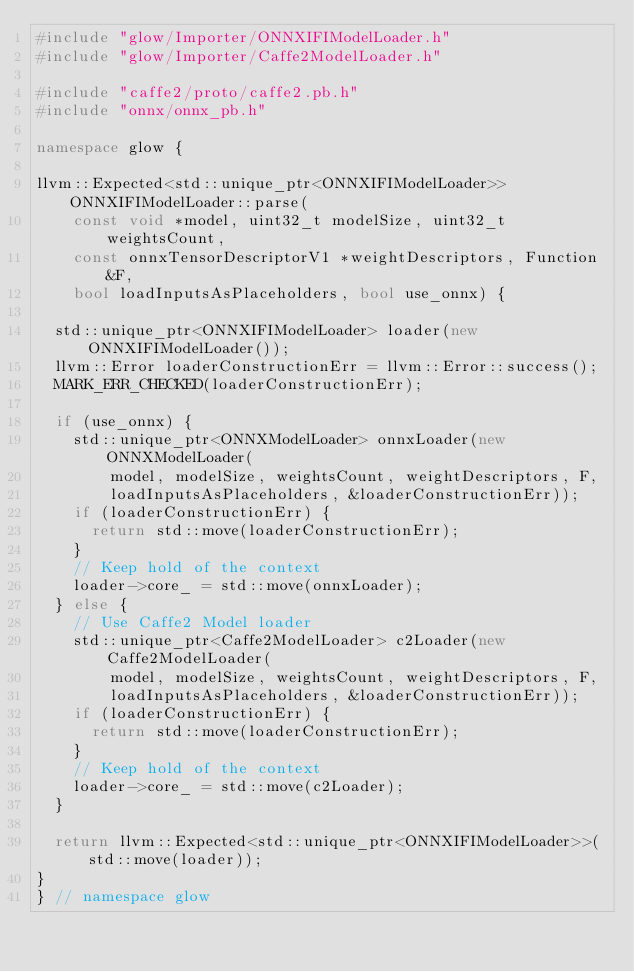<code> <loc_0><loc_0><loc_500><loc_500><_C++_>#include "glow/Importer/ONNXIFIModelLoader.h"
#include "glow/Importer/Caffe2ModelLoader.h"

#include "caffe2/proto/caffe2.pb.h"
#include "onnx/onnx_pb.h"

namespace glow {

llvm::Expected<std::unique_ptr<ONNXIFIModelLoader>> ONNXIFIModelLoader::parse(
    const void *model, uint32_t modelSize, uint32_t weightsCount,
    const onnxTensorDescriptorV1 *weightDescriptors, Function &F,
    bool loadInputsAsPlaceholders, bool use_onnx) {

  std::unique_ptr<ONNXIFIModelLoader> loader(new ONNXIFIModelLoader());
  llvm::Error loaderConstructionErr = llvm::Error::success();
  MARK_ERR_CHECKED(loaderConstructionErr);

  if (use_onnx) {
    std::unique_ptr<ONNXModelLoader> onnxLoader(new ONNXModelLoader(
        model, modelSize, weightsCount, weightDescriptors, F,
        loadInputsAsPlaceholders, &loaderConstructionErr));
    if (loaderConstructionErr) {
      return std::move(loaderConstructionErr);
    }
    // Keep hold of the context
    loader->core_ = std::move(onnxLoader);
  } else {
    // Use Caffe2 Model loader
    std::unique_ptr<Caffe2ModelLoader> c2Loader(new Caffe2ModelLoader(
        model, modelSize, weightsCount, weightDescriptors, F,
        loadInputsAsPlaceholders, &loaderConstructionErr));
    if (loaderConstructionErr) {
      return std::move(loaderConstructionErr);
    }
    // Keep hold of the context
    loader->core_ = std::move(c2Loader);
  }

  return llvm::Expected<std::unique_ptr<ONNXIFIModelLoader>>(std::move(loader));
}
} // namespace glow
</code> 